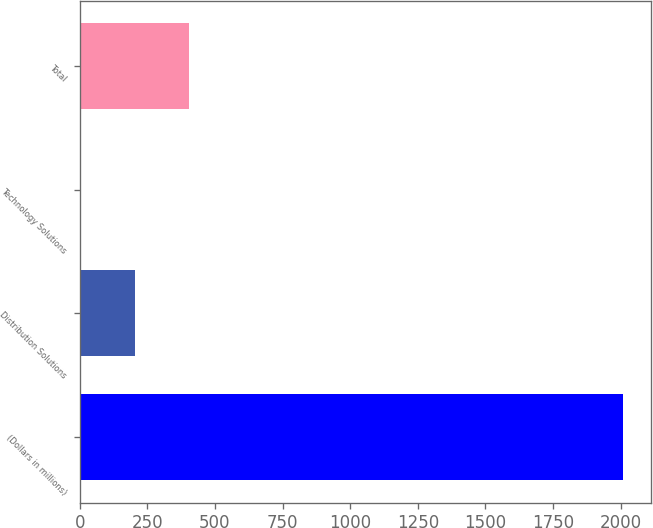Convert chart. <chart><loc_0><loc_0><loc_500><loc_500><bar_chart><fcel>(Dollars in millions)<fcel>Distribution Solutions<fcel>Technology Solutions<fcel>Total<nl><fcel>2010<fcel>205.5<fcel>5<fcel>406<nl></chart> 